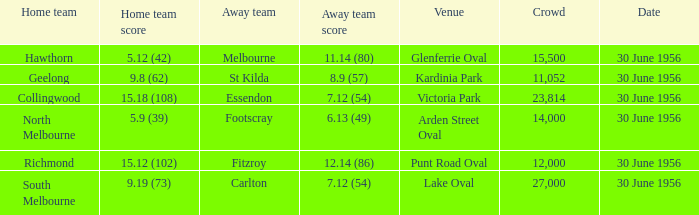What away team has a home team score of 15.18 (108)? Essendon. Could you help me parse every detail presented in this table? {'header': ['Home team', 'Home team score', 'Away team', 'Away team score', 'Venue', 'Crowd', 'Date'], 'rows': [['Hawthorn', '5.12 (42)', 'Melbourne', '11.14 (80)', 'Glenferrie Oval', '15,500', '30 June 1956'], ['Geelong', '9.8 (62)', 'St Kilda', '8.9 (57)', 'Kardinia Park', '11,052', '30 June 1956'], ['Collingwood', '15.18 (108)', 'Essendon', '7.12 (54)', 'Victoria Park', '23,814', '30 June 1956'], ['North Melbourne', '5.9 (39)', 'Footscray', '6.13 (49)', 'Arden Street Oval', '14,000', '30 June 1956'], ['Richmond', '15.12 (102)', 'Fitzroy', '12.14 (86)', 'Punt Road Oval', '12,000', '30 June 1956'], ['South Melbourne', '9.19 (73)', 'Carlton', '7.12 (54)', 'Lake Oval', '27,000', '30 June 1956']]} 